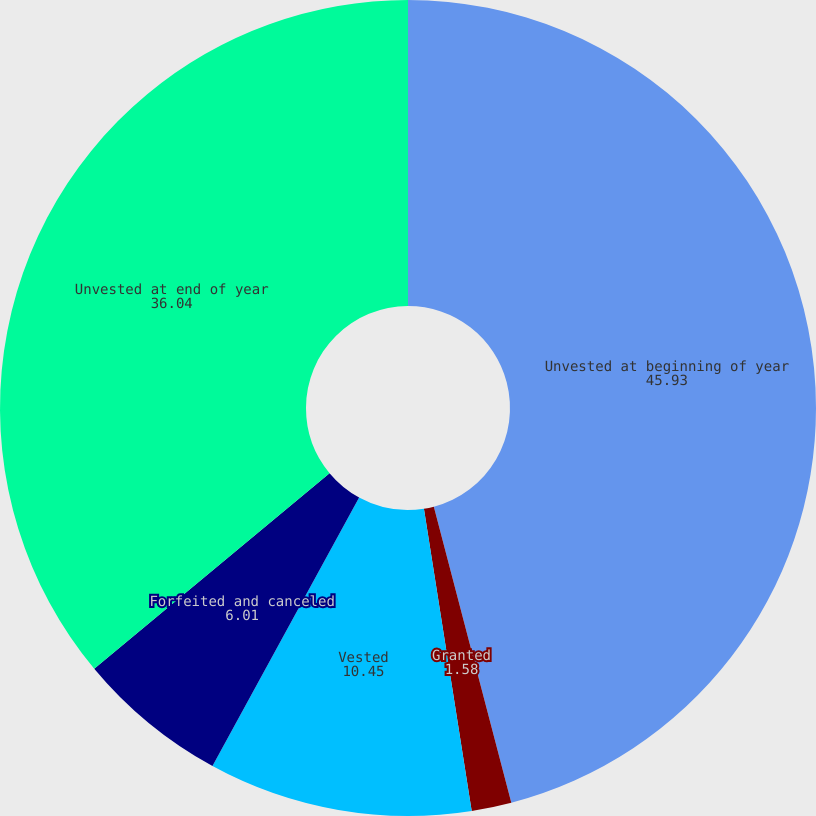Convert chart to OTSL. <chart><loc_0><loc_0><loc_500><loc_500><pie_chart><fcel>Unvested at beginning of year<fcel>Granted<fcel>Vested<fcel>Forfeited and canceled<fcel>Unvested at end of year<nl><fcel>45.93%<fcel>1.58%<fcel>10.45%<fcel>6.01%<fcel>36.04%<nl></chart> 